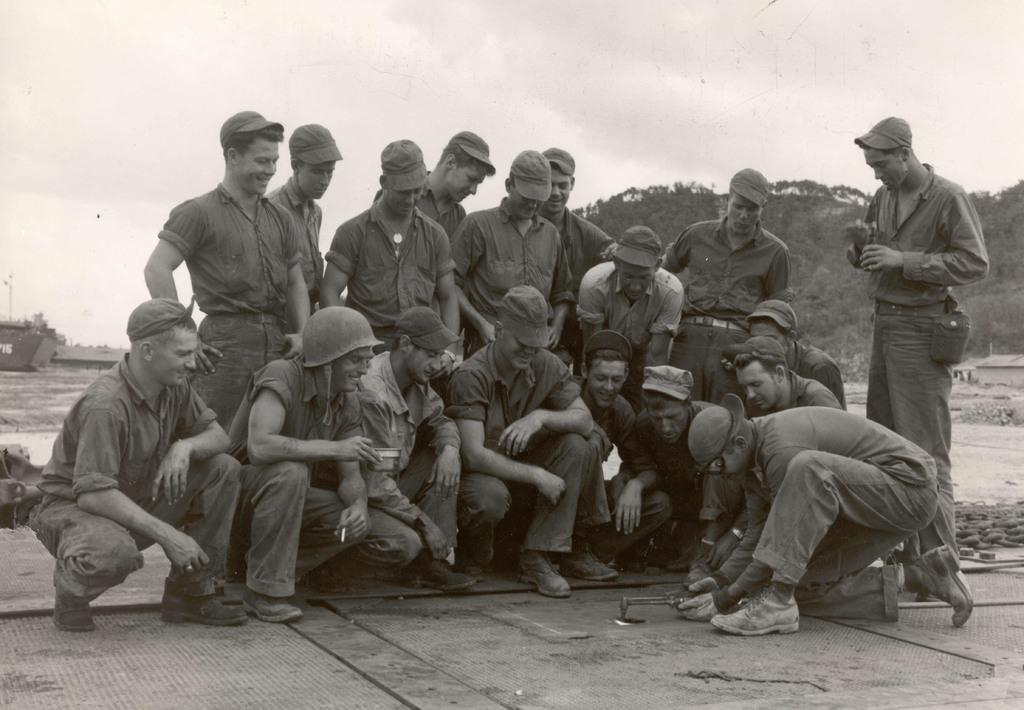Can you describe this image briefly? This image is black and white. In the center of the image some persons are there. In the background of the image trees, vehicle, pole are there. At the bottom of the image ground is there. At the top of the image clouds are present in the sky. 